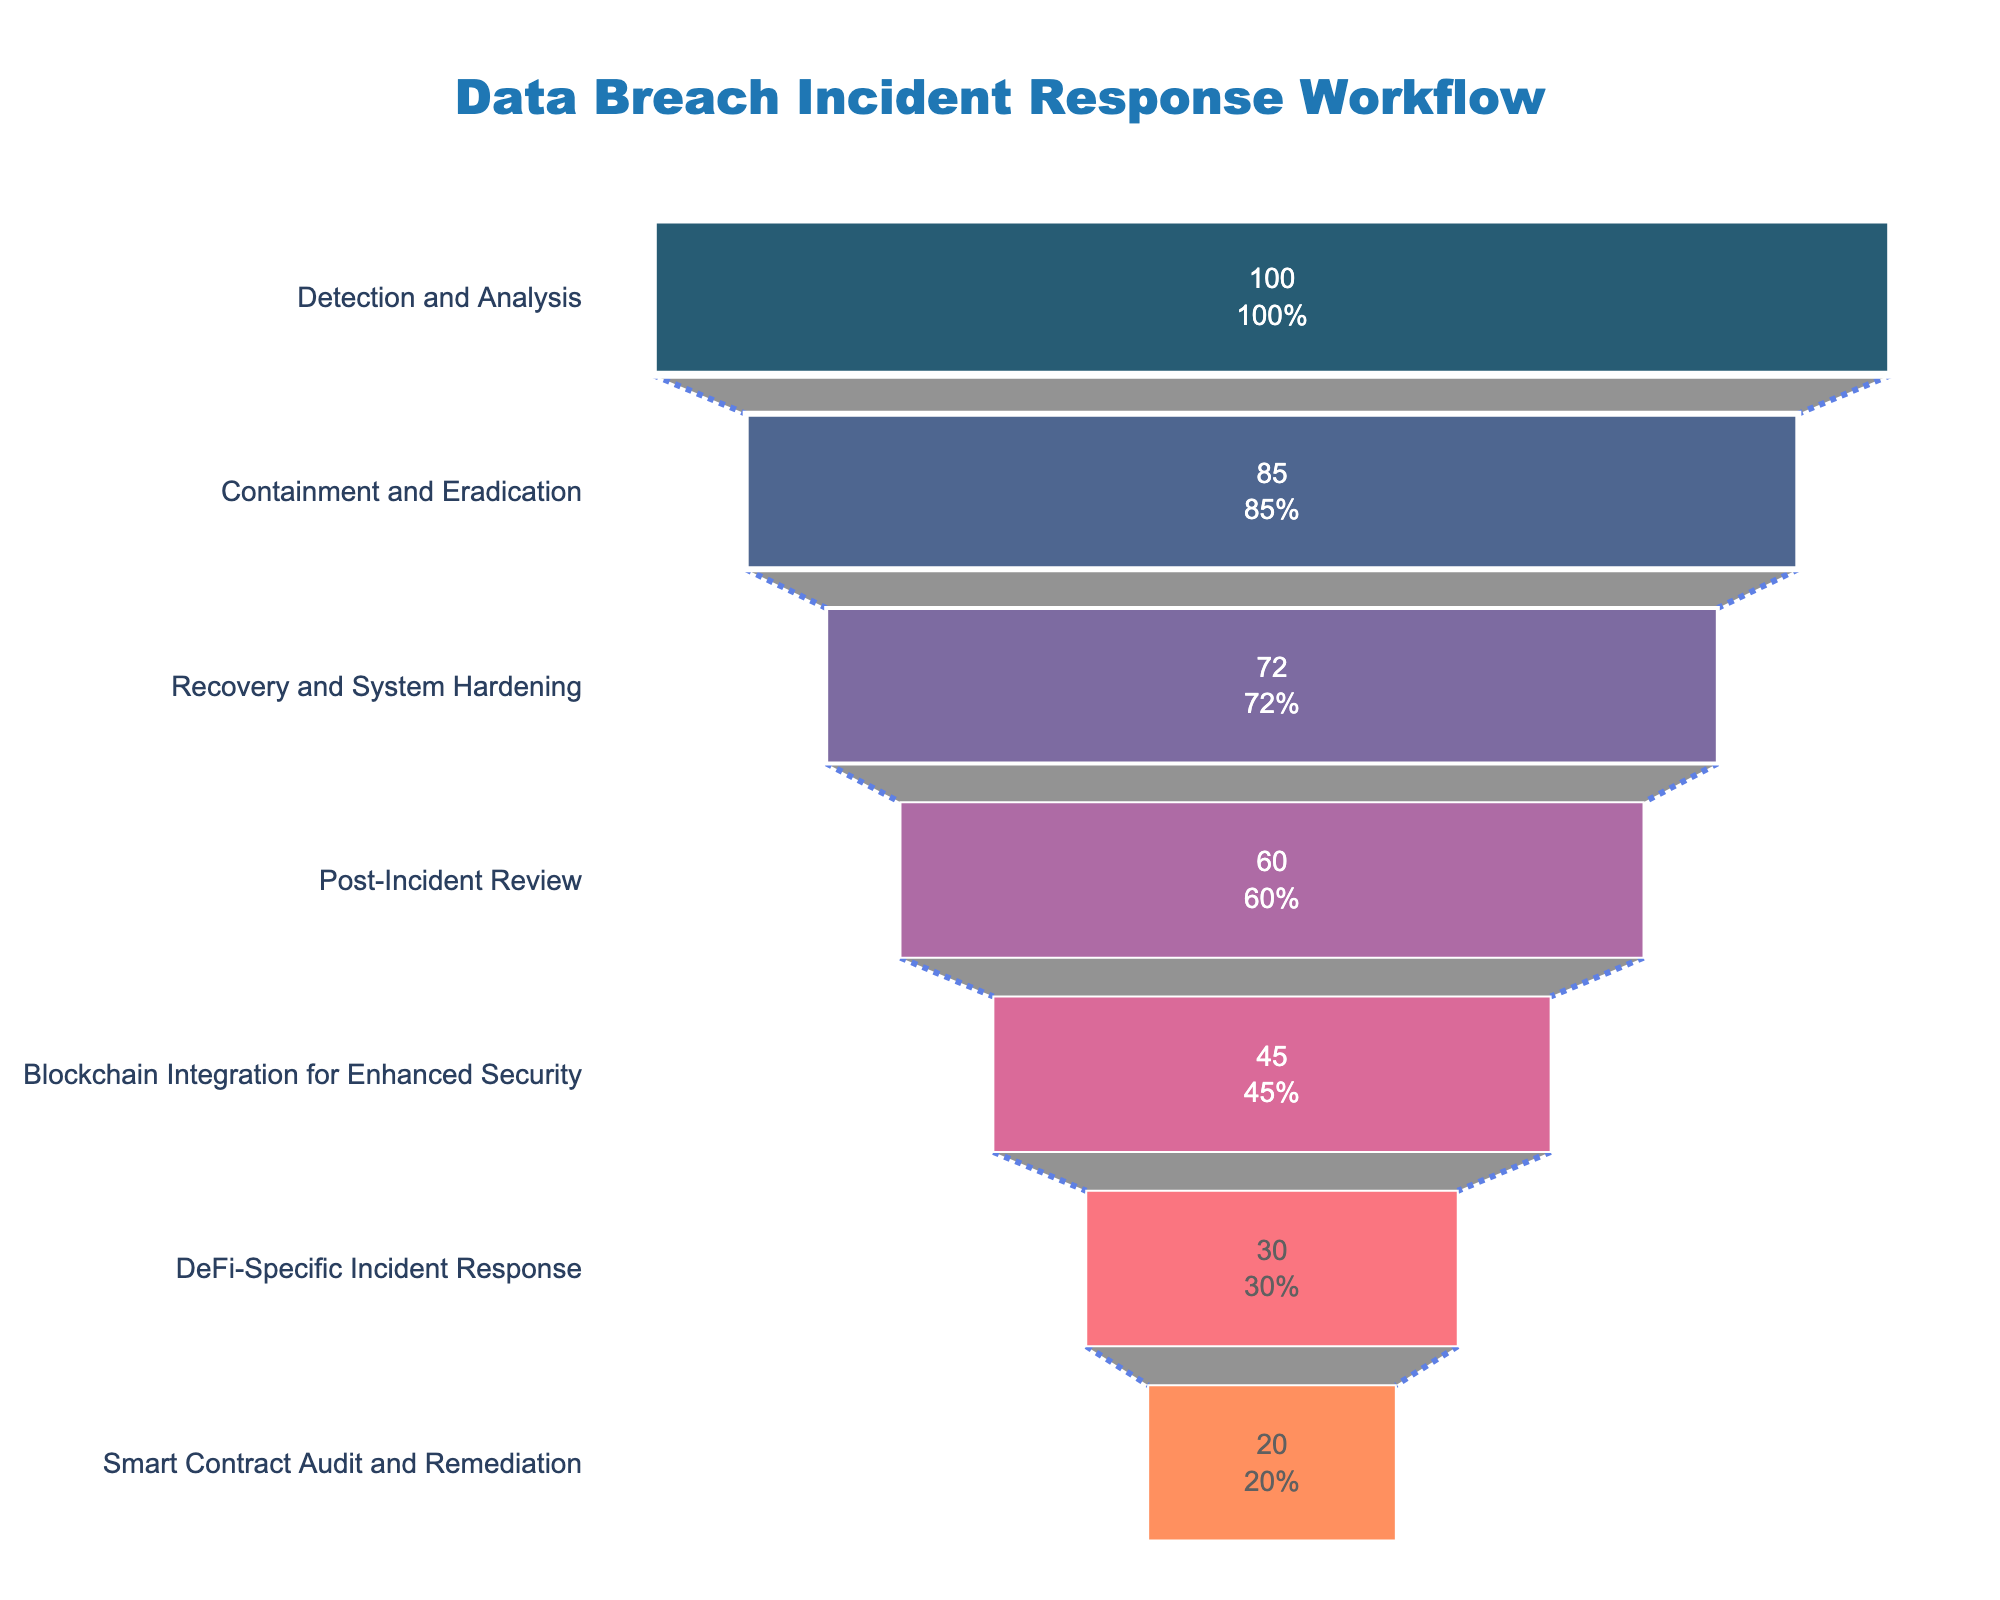What is the title of the funnel chart? The title can be found at the top of the chart, providing a clear description of what the figure represents.
Answer: Data Breach Incident Response Workflow How many phases are there in the workflow? Count the number of distinct phases listed vertically on the left side of the funnel chart.
Answer: 7 Which phase has the highest percentage of incidents resolved? Look for the phase with the largest value, typically at the widest section of the funnel.
Answer: Detection and Analysis What is the difference in the percentage of incidents resolved between the phases "Containment and Eradication" and "Post-Incident Review"? Subtract the percentage of incidents resolved in "Post-Incident Review" from "Containment and Eradication". 85% - 60% = 25%
Answer: 25% What is the cumulative percentage of incidents resolved by the end of the "Recovery and System Hardening" phase? Add the percentages for "Detection and Analysis", "Containment and Eradication", and "Recovery and System Hardening". 100% + 85% + 72% = 257%
Answer: 257% Which phase shows the largest drop in incident resolution percentage from the previous phase? Compare the differences in percentages between consecutive phases and identify the largest decrease. 720-600 (Recovery and System Hardening to Post-Incident Review) = -120 incidents. Convert to percentage. 72% - 60% = 12%.
Answer: Detection and Analysis to Containment and Eradication (15%) Is the percentage of incidents resolved greater in the "Blockchain Integration for Enhanced Security" phase or the "Smart Contract Audit and Remediation" phase? Compare the percentages of incidents resolved in both phases directly. 45% > 20%
Answer: Blockchain Integration for Enhanced Security What is the percentage of incidents resolved in the final phase "Smart Contract Audit and Remediation"? Look at the percentage value associated with the "Smart Contract Audit and Remediation" phase.
Answer: 20% Identify one area annotated in the chart. Review the extra text information provided in the chart, typically located at a specific annotation spot.
Answer: Securing Decentralized Finance What percentage of incidents are left unresolved by the end of the "Post-Incident Review" phase? The unresolved percentage after the last mentioned phase can be calculated by taking 100% - percentage resolved by the "Post-Incident Review" phase. 100% - 60% = 40%
Answer: 40% 